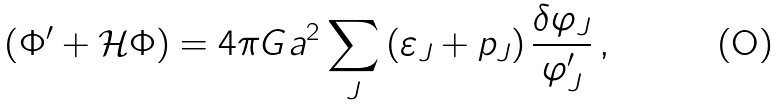Convert formula to latex. <formula><loc_0><loc_0><loc_500><loc_500>\left ( \Phi ^ { \prime } + \mathcal { H } \Phi \right ) = 4 \pi G a ^ { 2 } \sum _ { J } \left ( \varepsilon _ { J } + p _ { J } \right ) \frac { \delta \varphi _ { J } } { \varphi _ { J } ^ { \prime } } \, ,</formula> 